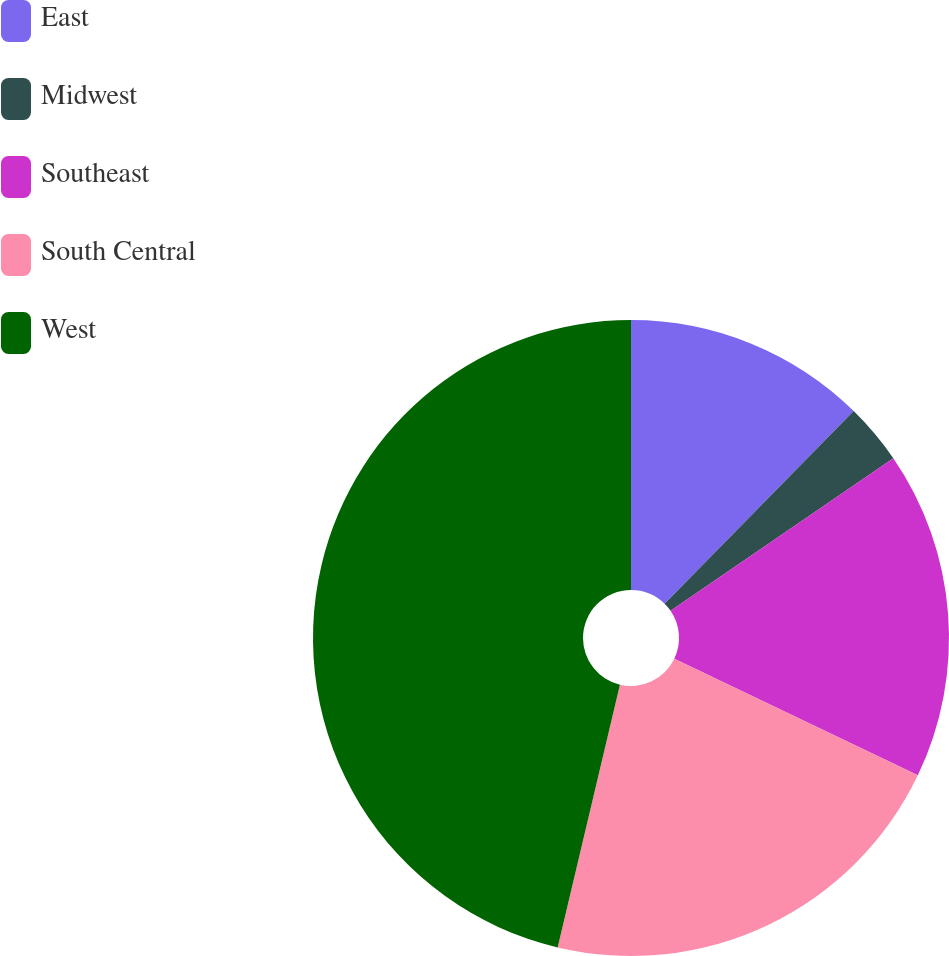Convert chart. <chart><loc_0><loc_0><loc_500><loc_500><pie_chart><fcel>East<fcel>Midwest<fcel>Southeast<fcel>South Central<fcel>West<nl><fcel>12.35%<fcel>3.09%<fcel>16.67%<fcel>21.6%<fcel>46.3%<nl></chart> 